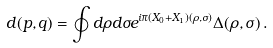<formula> <loc_0><loc_0><loc_500><loc_500>d ( p , q ) = \oint d \rho d \sigma e ^ { i \pi ( X _ { 0 } + X _ { 1 } ) ( \rho , \sigma ) } \Delta ( \rho , \sigma ) \, .</formula> 